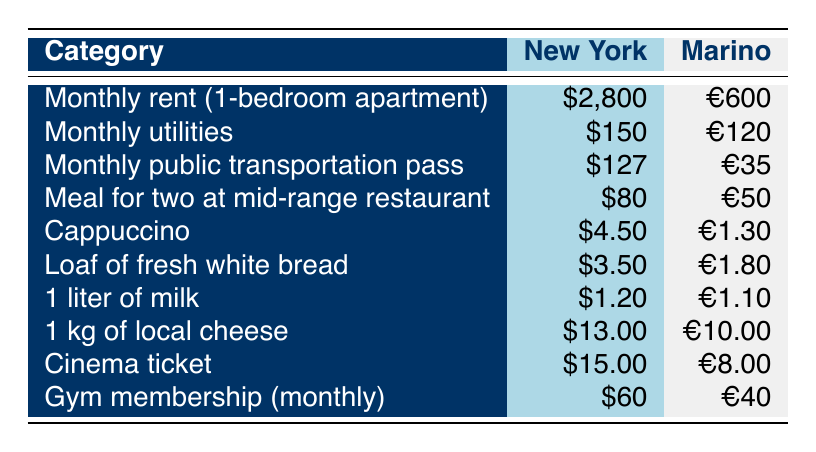What's the cost of a cappuccino in New York? The table lists the price of a cappuccino in New York as $4.50.
Answer: $4.50 What is the monthly rent for a 1-bedroom apartment in Marino? The table shows that the monthly rent for a 1-bedroom apartment in Marino is €600.
Answer: €600 Is a meal for two at a mid-range restaurant more expensive in Marino than in New York? The table states that a meal for two costs $80 in New York and €50 in Marino. Since €50 is less than $80 when converted, it's not true that Marino is more expensive.
Answer: No What is the total cost for a monthly transportation pass and monthly utilities in Marino? From the table, the cost of a monthly public transportation pass in Marino is €35 and monthly utilities are €120. Adding these gives €35 + €120 = €155.
Answer: €155 How much cheaper is the monthly rent in Marino compared to New York? Monthly rent in New York is $2,800 (approximately €2,520). Comparing this with €600 in Marino, the difference is €2,520 - €600 = €1,920.
Answer: €1,920 Is the cost of 1 kg of local cheese in Marino lower than in New York? According to the table, the cost of 1 kg of local cheese is $13.00 in New York and €10.00 in Marino. Since €10.00 is lower than $13.00 when converted, this statement is true.
Answer: Yes What percentage of the New York gym membership cost does a gym membership cost in Marino represent? The monthly gym membership in New York is $60, while in Marino it's €40. Converting €40 to dollars (approx. $44), the percentage is ($44 / $60) * 100 = 73.33%.
Answer: 73.33% What is the total cost of a loaf of bread and a liter of milk in Marino? The table lists the cost of a loaf of fresh white bread in Marino as €1.80 and 1 liter of milk as €1.10. Adding these gives €1.80 + €1.10 = €2.90.
Answer: €2.90 